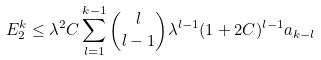<formula> <loc_0><loc_0><loc_500><loc_500>E _ { 2 } ^ { k } \leq \lambda ^ { 2 } C \sum ^ { k - 1 } _ { l = 1 } \binom { l } { l - 1 } \lambda ^ { l - 1 } ( 1 + 2 C ) ^ { l - 1 } a _ { k - l }</formula> 